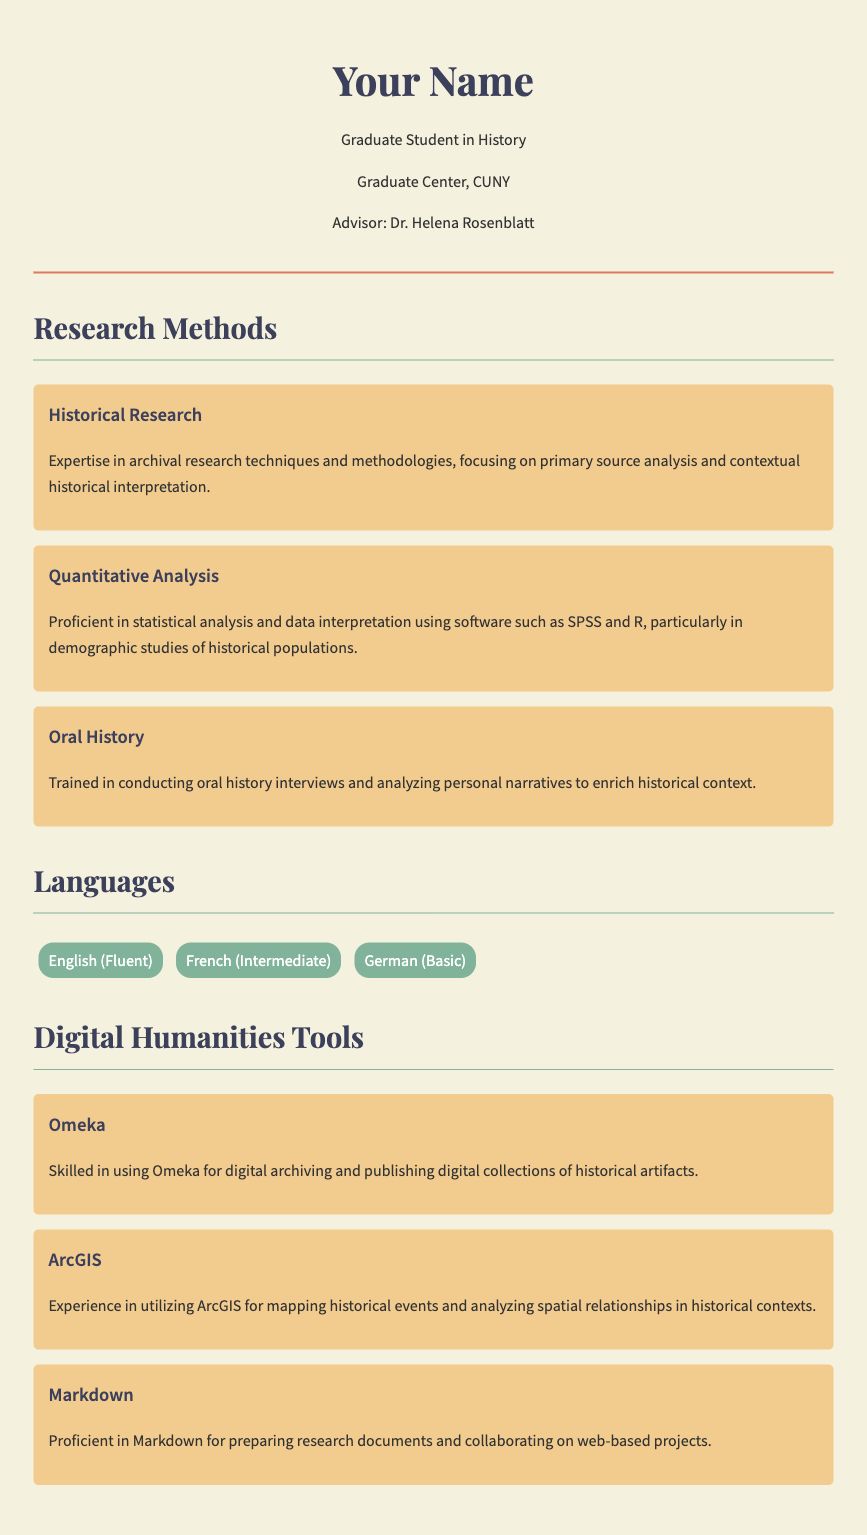What is the name of the advisor? The advisor's name is indicated under the student's details in the header section of the document.
Answer: Dr. Helena Rosenblatt How many languages are listed? The document specifically lists three languages under the Languages section.
Answer: Three What is the highest proficiency mentioned in languages? The English proficiency level is mentioned as fluent, indicating the highest level of proficiency in the document.
Answer: Fluent Which research method focuses on primary source analysis? The research methods section describes various methods, and archival research techniques particularly focus on primary sources.
Answer: Historical Research What tool is used for digital archiving? The document mentions a specific tool that is skilled in digital archiving and publishing collections.
Answer: Omeka What type of analysis is associated with SPSS and R? The document indicates a particular research method that employs SPSS and R for analysis related to historical populations.
Answer: Quantitative Analysis What proficiency level is indicated for German? In the Languages section, the proficiency level for German is stated alongside the language.
Answer: Basic Which digital humanities tool is used for mapping? The document specifies a tool that is utilized for mapping historical events.
Answer: ArcGIS What type of history is mentioned that involves personal narratives? The document refers to a method of research that incorporates interviews with individuals to add context to historical interpretation.
Answer: Oral History 